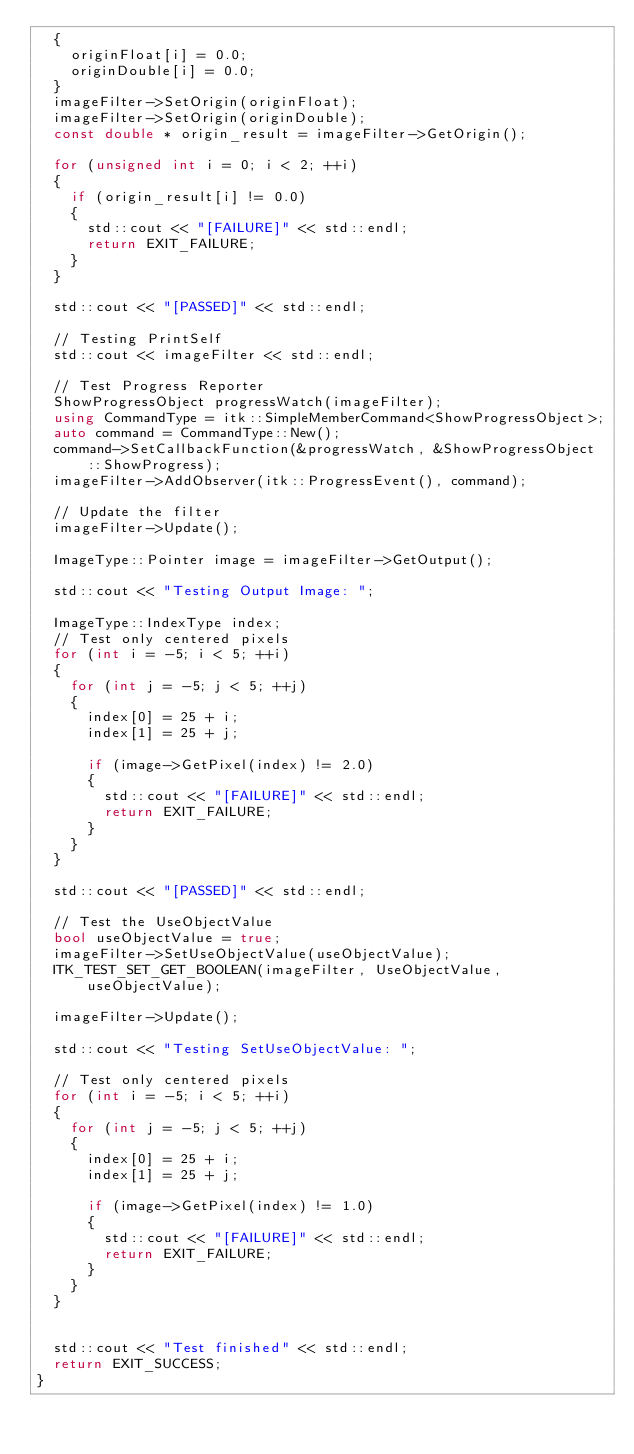Convert code to text. <code><loc_0><loc_0><loc_500><loc_500><_C++_>  {
    originFloat[i] = 0.0;
    originDouble[i] = 0.0;
  }
  imageFilter->SetOrigin(originFloat);
  imageFilter->SetOrigin(originDouble);
  const double * origin_result = imageFilter->GetOrigin();

  for (unsigned int i = 0; i < 2; ++i)
  {
    if (origin_result[i] != 0.0)
    {
      std::cout << "[FAILURE]" << std::endl;
      return EXIT_FAILURE;
    }
  }

  std::cout << "[PASSED]" << std::endl;

  // Testing PrintSelf
  std::cout << imageFilter << std::endl;

  // Test Progress Reporter
  ShowProgressObject progressWatch(imageFilter);
  using CommandType = itk::SimpleMemberCommand<ShowProgressObject>;
  auto command = CommandType::New();
  command->SetCallbackFunction(&progressWatch, &ShowProgressObject::ShowProgress);
  imageFilter->AddObserver(itk::ProgressEvent(), command);

  // Update the filter
  imageFilter->Update();

  ImageType::Pointer image = imageFilter->GetOutput();

  std::cout << "Testing Output Image: ";

  ImageType::IndexType index;
  // Test only centered pixels
  for (int i = -5; i < 5; ++i)
  {
    for (int j = -5; j < 5; ++j)
    {
      index[0] = 25 + i;
      index[1] = 25 + j;

      if (image->GetPixel(index) != 2.0)
      {
        std::cout << "[FAILURE]" << std::endl;
        return EXIT_FAILURE;
      }
    }
  }

  std::cout << "[PASSED]" << std::endl;

  // Test the UseObjectValue
  bool useObjectValue = true;
  imageFilter->SetUseObjectValue(useObjectValue);
  ITK_TEST_SET_GET_BOOLEAN(imageFilter, UseObjectValue, useObjectValue);

  imageFilter->Update();

  std::cout << "Testing SetUseObjectValue: ";

  // Test only centered pixels
  for (int i = -5; i < 5; ++i)
  {
    for (int j = -5; j < 5; ++j)
    {
      index[0] = 25 + i;
      index[1] = 25 + j;

      if (image->GetPixel(index) != 1.0)
      {
        std::cout << "[FAILURE]" << std::endl;
        return EXIT_FAILURE;
      }
    }
  }


  std::cout << "Test finished" << std::endl;
  return EXIT_SUCCESS;
}
</code> 